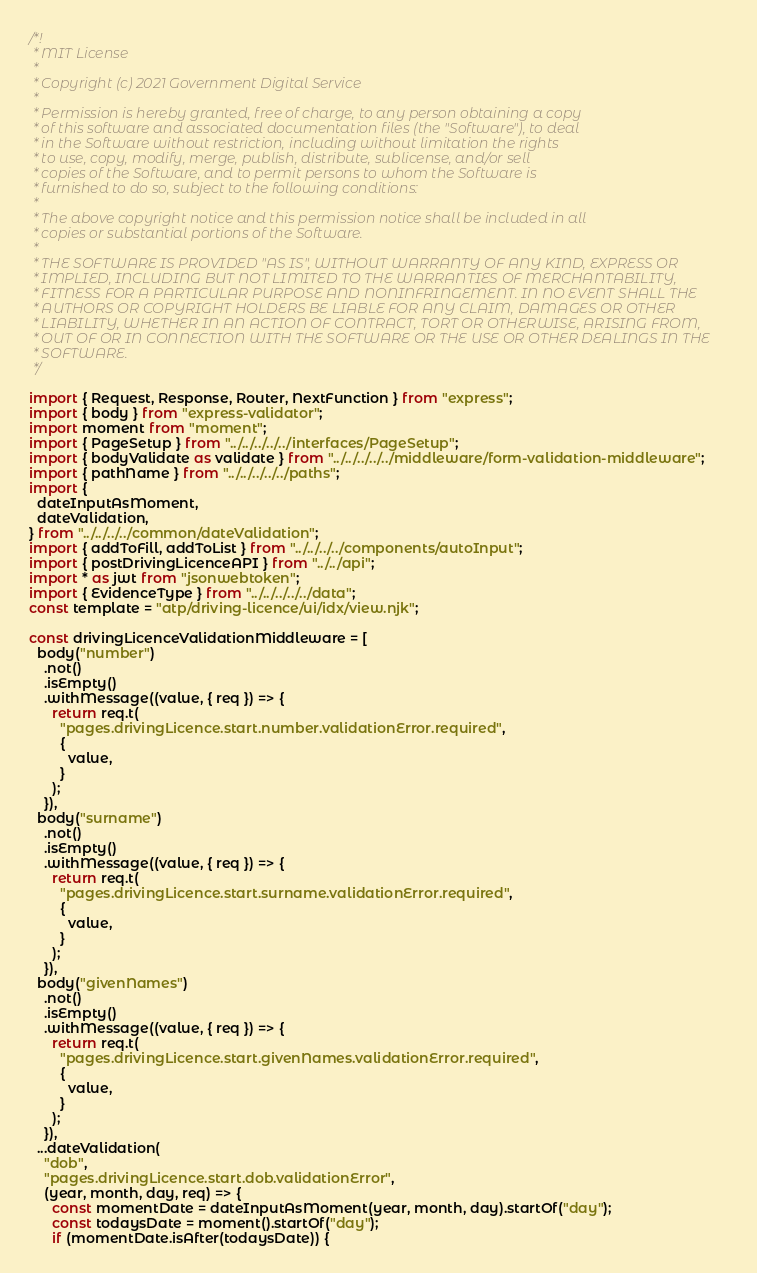<code> <loc_0><loc_0><loc_500><loc_500><_TypeScript_>/*!
 * MIT License
 *
 * Copyright (c) 2021 Government Digital Service
 *
 * Permission is hereby granted, free of charge, to any person obtaining a copy
 * of this software and associated documentation files (the "Software"), to deal
 * in the Software without restriction, including without limitation the rights
 * to use, copy, modify, merge, publish, distribute, sublicense, and/or sell
 * copies of the Software, and to permit persons to whom the Software is
 * furnished to do so, subject to the following conditions:
 *
 * The above copyright notice and this permission notice shall be included in all
 * copies or substantial portions of the Software.
 *
 * THE SOFTWARE IS PROVIDED "AS IS", WITHOUT WARRANTY OF ANY KIND, EXPRESS OR
 * IMPLIED, INCLUDING BUT NOT LIMITED TO THE WARRANTIES OF MERCHANTABILITY,
 * FITNESS FOR A PARTICULAR PURPOSE AND NONINFRINGEMENT. IN NO EVENT SHALL THE
 * AUTHORS OR COPYRIGHT HOLDERS BE LIABLE FOR ANY CLAIM, DAMAGES OR OTHER
 * LIABILITY, WHETHER IN AN ACTION OF CONTRACT, TORT OR OTHERWISE, ARISING FROM,
 * OUT OF OR IN CONNECTION WITH THE SOFTWARE OR THE USE OR OTHER DEALINGS IN THE
 * SOFTWARE.
 */

import { Request, Response, Router, NextFunction } from "express";
import { body } from "express-validator";
import moment from "moment";
import { PageSetup } from "../../../../../interfaces/PageSetup";
import { bodyValidate as validate } from "../../../../../middleware/form-validation-middleware";
import { pathName } from "../../../../../paths";
import {
  dateInputAsMoment,
  dateValidation,
} from "../../../../common/dateValidation";
import { addToFill, addToList } from "../../../../components/autoInput";
import { postDrivingLicenceAPI } from "../../api";
import * as jwt from "jsonwebtoken";
import { EvidenceType } from "../../../../../data";
const template = "atp/driving-licence/ui/idx/view.njk";

const drivingLicenceValidationMiddleware = [
  body("number")
    .not()
    .isEmpty()
    .withMessage((value, { req }) => {
      return req.t(
        "pages.drivingLicence.start.number.validationError.required",
        {
          value,
        }
      );
    }),
  body("surname")
    .not()
    .isEmpty()
    .withMessage((value, { req }) => {
      return req.t(
        "pages.drivingLicence.start.surname.validationError.required",
        {
          value,
        }
      );
    }),
  body("givenNames")
    .not()
    .isEmpty()
    .withMessage((value, { req }) => {
      return req.t(
        "pages.drivingLicence.start.givenNames.validationError.required",
        {
          value,
        }
      );
    }),
  ...dateValidation(
    "dob",
    "pages.drivingLicence.start.dob.validationError",
    (year, month, day, req) => {
      const momentDate = dateInputAsMoment(year, month, day).startOf("day");
      const todaysDate = moment().startOf("day");
      if (momentDate.isAfter(todaysDate)) {</code> 